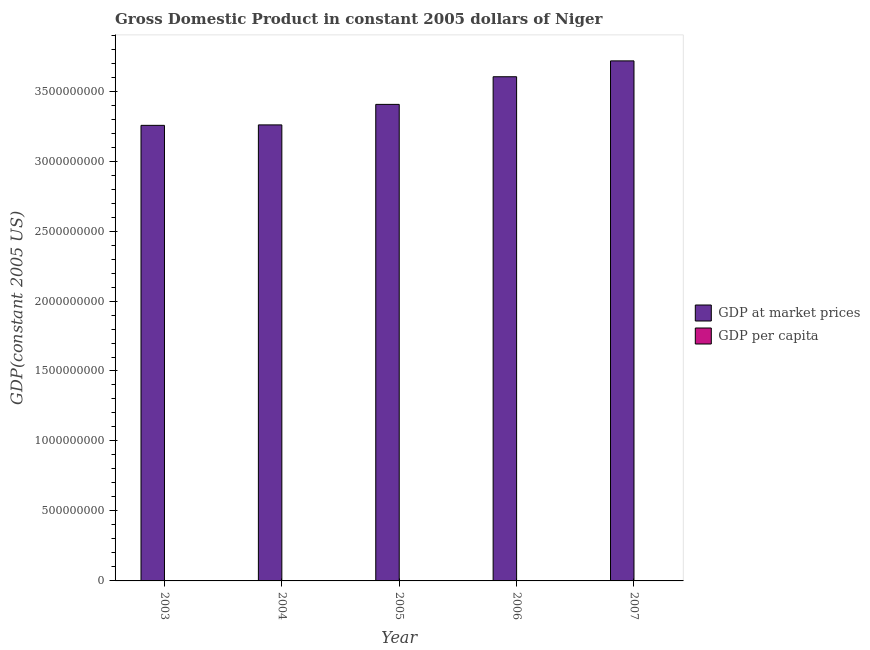How many different coloured bars are there?
Make the answer very short. 2. How many groups of bars are there?
Provide a succinct answer. 5. Are the number of bars per tick equal to the number of legend labels?
Keep it short and to the point. Yes. How many bars are there on the 3rd tick from the left?
Your answer should be very brief. 2. How many bars are there on the 4th tick from the right?
Ensure brevity in your answer.  2. What is the label of the 1st group of bars from the left?
Make the answer very short. 2003. In how many cases, is the number of bars for a given year not equal to the number of legend labels?
Provide a short and direct response. 0. What is the gdp at market prices in 2004?
Your response must be concise. 3.26e+09. Across all years, what is the maximum gdp at market prices?
Make the answer very short. 3.72e+09. Across all years, what is the minimum gdp at market prices?
Offer a terse response. 3.26e+09. What is the total gdp per capita in the graph?
Provide a succinct answer. 1276.3. What is the difference between the gdp at market prices in 2005 and that in 2007?
Provide a short and direct response. -3.11e+08. What is the difference between the gdp per capita in 2003 and the gdp at market prices in 2005?
Make the answer very short. 7.36. What is the average gdp at market prices per year?
Provide a short and direct response. 3.45e+09. In how many years, is the gdp per capita greater than 900000000 US$?
Your answer should be compact. 0. What is the ratio of the gdp at market prices in 2003 to that in 2006?
Ensure brevity in your answer.  0.9. Is the gdp at market prices in 2004 less than that in 2006?
Keep it short and to the point. Yes. Is the difference between the gdp per capita in 2004 and 2006 greater than the difference between the gdp at market prices in 2004 and 2006?
Your answer should be compact. No. What is the difference between the highest and the second highest gdp per capita?
Provide a short and direct response. 2.45. What is the difference between the highest and the lowest gdp at market prices?
Ensure brevity in your answer.  4.61e+08. What does the 2nd bar from the left in 2004 represents?
Your answer should be compact. GDP per capita. What does the 2nd bar from the right in 2007 represents?
Provide a succinct answer. GDP at market prices. How many bars are there?
Offer a very short reply. 10. How many years are there in the graph?
Your answer should be compact. 5. What is the difference between two consecutive major ticks on the Y-axis?
Offer a very short reply. 5.00e+08. Are the values on the major ticks of Y-axis written in scientific E-notation?
Your response must be concise. No. How are the legend labels stacked?
Keep it short and to the point. Vertical. What is the title of the graph?
Provide a succinct answer. Gross Domestic Product in constant 2005 dollars of Niger. Does "Secondary education" appear as one of the legend labels in the graph?
Your answer should be very brief. No. What is the label or title of the Y-axis?
Give a very brief answer. GDP(constant 2005 US). What is the GDP(constant 2005 US) of GDP at market prices in 2003?
Provide a short and direct response. 3.26e+09. What is the GDP(constant 2005 US) in GDP per capita in 2003?
Provide a succinct answer. 259.86. What is the GDP(constant 2005 US) in GDP at market prices in 2004?
Offer a very short reply. 3.26e+09. What is the GDP(constant 2005 US) in GDP per capita in 2004?
Provide a short and direct response. 250.73. What is the GDP(constant 2005 US) in GDP at market prices in 2005?
Make the answer very short. 3.41e+09. What is the GDP(constant 2005 US) of GDP per capita in 2005?
Offer a very short reply. 252.5. What is the GDP(constant 2005 US) in GDP at market prices in 2006?
Make the answer very short. 3.60e+09. What is the GDP(constant 2005 US) of GDP per capita in 2006?
Keep it short and to the point. 257.41. What is the GDP(constant 2005 US) of GDP at market prices in 2007?
Offer a terse response. 3.72e+09. What is the GDP(constant 2005 US) in GDP per capita in 2007?
Give a very brief answer. 255.79. Across all years, what is the maximum GDP(constant 2005 US) of GDP at market prices?
Ensure brevity in your answer.  3.72e+09. Across all years, what is the maximum GDP(constant 2005 US) in GDP per capita?
Your answer should be compact. 259.86. Across all years, what is the minimum GDP(constant 2005 US) in GDP at market prices?
Offer a very short reply. 3.26e+09. Across all years, what is the minimum GDP(constant 2005 US) of GDP per capita?
Your response must be concise. 250.73. What is the total GDP(constant 2005 US) of GDP at market prices in the graph?
Provide a succinct answer. 1.72e+1. What is the total GDP(constant 2005 US) of GDP per capita in the graph?
Ensure brevity in your answer.  1276.3. What is the difference between the GDP(constant 2005 US) in GDP at market prices in 2003 and that in 2004?
Provide a succinct answer. -3.26e+06. What is the difference between the GDP(constant 2005 US) in GDP per capita in 2003 and that in 2004?
Make the answer very short. 9.13. What is the difference between the GDP(constant 2005 US) in GDP at market prices in 2003 and that in 2005?
Provide a short and direct response. -1.50e+08. What is the difference between the GDP(constant 2005 US) in GDP per capita in 2003 and that in 2005?
Give a very brief answer. 7.36. What is the difference between the GDP(constant 2005 US) in GDP at market prices in 2003 and that in 2006?
Offer a terse response. -3.47e+08. What is the difference between the GDP(constant 2005 US) in GDP per capita in 2003 and that in 2006?
Your answer should be compact. 2.45. What is the difference between the GDP(constant 2005 US) in GDP at market prices in 2003 and that in 2007?
Ensure brevity in your answer.  -4.61e+08. What is the difference between the GDP(constant 2005 US) of GDP per capita in 2003 and that in 2007?
Provide a short and direct response. 4.08. What is the difference between the GDP(constant 2005 US) in GDP at market prices in 2004 and that in 2005?
Offer a very short reply. -1.47e+08. What is the difference between the GDP(constant 2005 US) in GDP per capita in 2004 and that in 2005?
Keep it short and to the point. -1.77. What is the difference between the GDP(constant 2005 US) of GDP at market prices in 2004 and that in 2006?
Ensure brevity in your answer.  -3.44e+08. What is the difference between the GDP(constant 2005 US) in GDP per capita in 2004 and that in 2006?
Your answer should be very brief. -6.68. What is the difference between the GDP(constant 2005 US) in GDP at market prices in 2004 and that in 2007?
Ensure brevity in your answer.  -4.57e+08. What is the difference between the GDP(constant 2005 US) of GDP per capita in 2004 and that in 2007?
Make the answer very short. -5.06. What is the difference between the GDP(constant 2005 US) in GDP at market prices in 2005 and that in 2006?
Your answer should be compact. -1.97e+08. What is the difference between the GDP(constant 2005 US) in GDP per capita in 2005 and that in 2006?
Provide a succinct answer. -4.91. What is the difference between the GDP(constant 2005 US) in GDP at market prices in 2005 and that in 2007?
Provide a short and direct response. -3.11e+08. What is the difference between the GDP(constant 2005 US) of GDP per capita in 2005 and that in 2007?
Offer a terse response. -3.28. What is the difference between the GDP(constant 2005 US) of GDP at market prices in 2006 and that in 2007?
Make the answer very short. -1.13e+08. What is the difference between the GDP(constant 2005 US) of GDP per capita in 2006 and that in 2007?
Give a very brief answer. 1.63. What is the difference between the GDP(constant 2005 US) in GDP at market prices in 2003 and the GDP(constant 2005 US) in GDP per capita in 2004?
Provide a short and direct response. 3.26e+09. What is the difference between the GDP(constant 2005 US) of GDP at market prices in 2003 and the GDP(constant 2005 US) of GDP per capita in 2005?
Your answer should be compact. 3.26e+09. What is the difference between the GDP(constant 2005 US) of GDP at market prices in 2003 and the GDP(constant 2005 US) of GDP per capita in 2006?
Provide a short and direct response. 3.26e+09. What is the difference between the GDP(constant 2005 US) in GDP at market prices in 2003 and the GDP(constant 2005 US) in GDP per capita in 2007?
Give a very brief answer. 3.26e+09. What is the difference between the GDP(constant 2005 US) of GDP at market prices in 2004 and the GDP(constant 2005 US) of GDP per capita in 2005?
Keep it short and to the point. 3.26e+09. What is the difference between the GDP(constant 2005 US) of GDP at market prices in 2004 and the GDP(constant 2005 US) of GDP per capita in 2006?
Your response must be concise. 3.26e+09. What is the difference between the GDP(constant 2005 US) of GDP at market prices in 2004 and the GDP(constant 2005 US) of GDP per capita in 2007?
Give a very brief answer. 3.26e+09. What is the difference between the GDP(constant 2005 US) in GDP at market prices in 2005 and the GDP(constant 2005 US) in GDP per capita in 2006?
Ensure brevity in your answer.  3.41e+09. What is the difference between the GDP(constant 2005 US) in GDP at market prices in 2005 and the GDP(constant 2005 US) in GDP per capita in 2007?
Keep it short and to the point. 3.41e+09. What is the difference between the GDP(constant 2005 US) of GDP at market prices in 2006 and the GDP(constant 2005 US) of GDP per capita in 2007?
Your response must be concise. 3.60e+09. What is the average GDP(constant 2005 US) of GDP at market prices per year?
Your response must be concise. 3.45e+09. What is the average GDP(constant 2005 US) of GDP per capita per year?
Give a very brief answer. 255.26. In the year 2003, what is the difference between the GDP(constant 2005 US) in GDP at market prices and GDP(constant 2005 US) in GDP per capita?
Your answer should be compact. 3.26e+09. In the year 2004, what is the difference between the GDP(constant 2005 US) in GDP at market prices and GDP(constant 2005 US) in GDP per capita?
Your answer should be very brief. 3.26e+09. In the year 2005, what is the difference between the GDP(constant 2005 US) in GDP at market prices and GDP(constant 2005 US) in GDP per capita?
Give a very brief answer. 3.41e+09. In the year 2006, what is the difference between the GDP(constant 2005 US) of GDP at market prices and GDP(constant 2005 US) of GDP per capita?
Ensure brevity in your answer.  3.60e+09. In the year 2007, what is the difference between the GDP(constant 2005 US) of GDP at market prices and GDP(constant 2005 US) of GDP per capita?
Give a very brief answer. 3.72e+09. What is the ratio of the GDP(constant 2005 US) in GDP per capita in 2003 to that in 2004?
Ensure brevity in your answer.  1.04. What is the ratio of the GDP(constant 2005 US) in GDP at market prices in 2003 to that in 2005?
Provide a succinct answer. 0.96. What is the ratio of the GDP(constant 2005 US) in GDP per capita in 2003 to that in 2005?
Offer a terse response. 1.03. What is the ratio of the GDP(constant 2005 US) in GDP at market prices in 2003 to that in 2006?
Offer a terse response. 0.9. What is the ratio of the GDP(constant 2005 US) of GDP per capita in 2003 to that in 2006?
Your answer should be very brief. 1.01. What is the ratio of the GDP(constant 2005 US) of GDP at market prices in 2003 to that in 2007?
Keep it short and to the point. 0.88. What is the ratio of the GDP(constant 2005 US) in GDP per capita in 2003 to that in 2007?
Offer a terse response. 1.02. What is the ratio of the GDP(constant 2005 US) in GDP at market prices in 2004 to that in 2005?
Offer a terse response. 0.96. What is the ratio of the GDP(constant 2005 US) in GDP per capita in 2004 to that in 2005?
Ensure brevity in your answer.  0.99. What is the ratio of the GDP(constant 2005 US) in GDP at market prices in 2004 to that in 2006?
Make the answer very short. 0.9. What is the ratio of the GDP(constant 2005 US) in GDP at market prices in 2004 to that in 2007?
Offer a very short reply. 0.88. What is the ratio of the GDP(constant 2005 US) in GDP per capita in 2004 to that in 2007?
Ensure brevity in your answer.  0.98. What is the ratio of the GDP(constant 2005 US) in GDP at market prices in 2005 to that in 2006?
Offer a terse response. 0.95. What is the ratio of the GDP(constant 2005 US) in GDP per capita in 2005 to that in 2006?
Your response must be concise. 0.98. What is the ratio of the GDP(constant 2005 US) in GDP at market prices in 2005 to that in 2007?
Give a very brief answer. 0.92. What is the ratio of the GDP(constant 2005 US) of GDP per capita in 2005 to that in 2007?
Keep it short and to the point. 0.99. What is the ratio of the GDP(constant 2005 US) of GDP at market prices in 2006 to that in 2007?
Provide a short and direct response. 0.97. What is the ratio of the GDP(constant 2005 US) of GDP per capita in 2006 to that in 2007?
Provide a short and direct response. 1.01. What is the difference between the highest and the second highest GDP(constant 2005 US) of GDP at market prices?
Make the answer very short. 1.13e+08. What is the difference between the highest and the second highest GDP(constant 2005 US) in GDP per capita?
Your answer should be very brief. 2.45. What is the difference between the highest and the lowest GDP(constant 2005 US) of GDP at market prices?
Ensure brevity in your answer.  4.61e+08. What is the difference between the highest and the lowest GDP(constant 2005 US) of GDP per capita?
Provide a short and direct response. 9.13. 